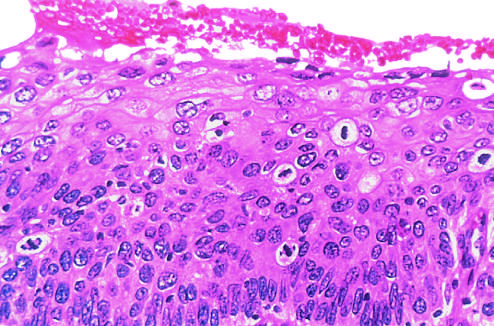s the intact basement membrane not seen in this section?
Answer the question using a single word or phrase. Yes 